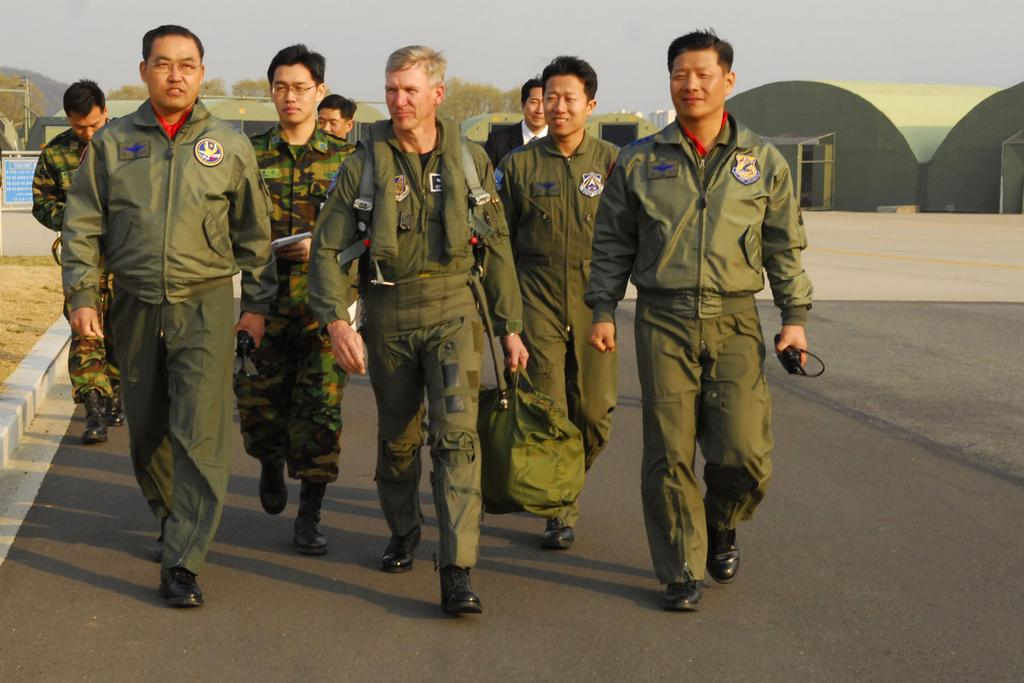How many people are in the image? There is a group of people in the image. What are the people doing in the image? The people are walking on a road. What can be seen in the background of the image? There are buildings, trees, a pole, and a board visible in the background. What type of teeth can be seen on the pole in the image? There are no teeth present on the pole in the image. How many bikes are being ridden by the people in the image? There is no mention of bikes in the image; the people are walking on a road. 